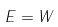Convert formula to latex. <formula><loc_0><loc_0><loc_500><loc_500>E = W</formula> 